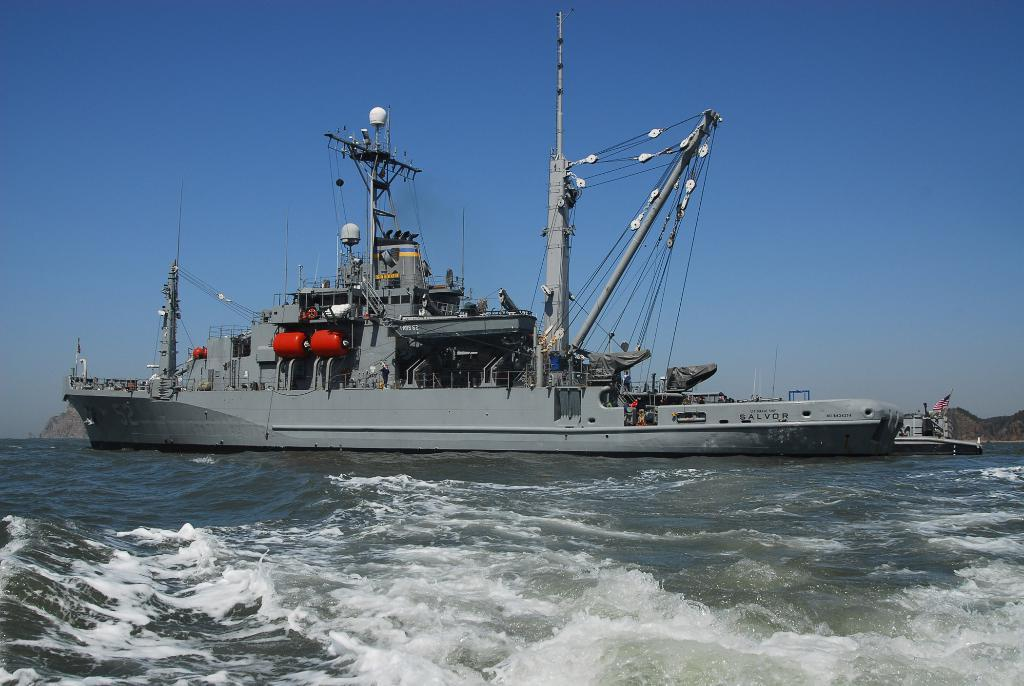What type of watercraft can be seen in the image? There is a ship and a boat in the image. Where are the ship and boat located? Both the ship and boat are on the water in the image. What type of landscape can be seen in the image? There are hills visible in the image. What is visible in the background of the image? The sky is visible in the background of the image. What type of punishment is being given to the river in the image? There is no river present in the image, and therefore no punishment can be given. 